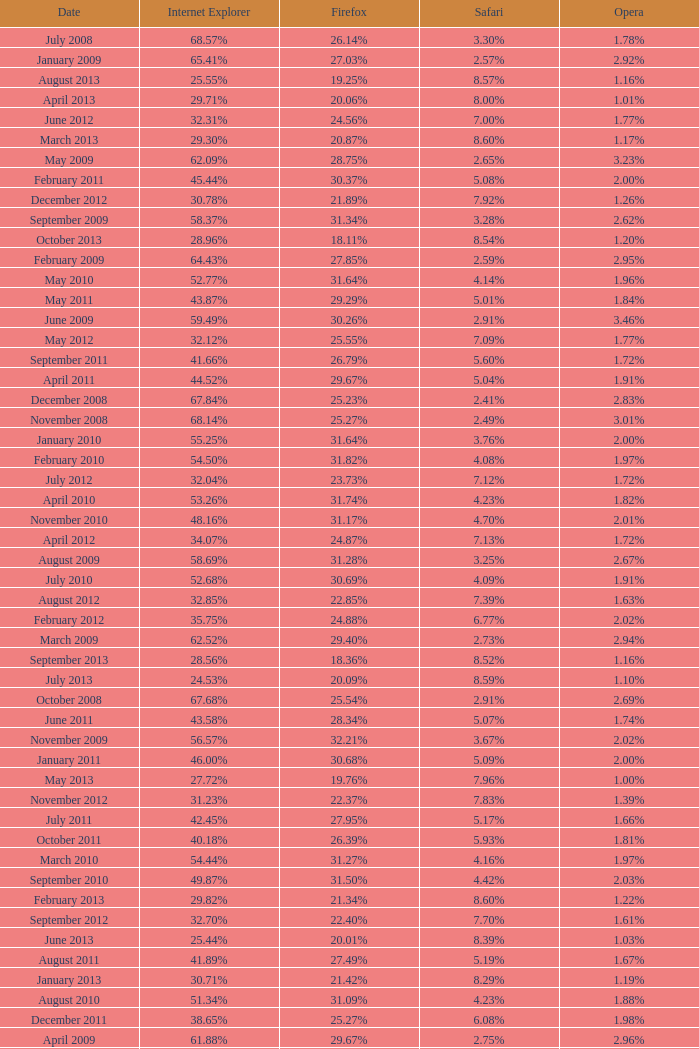What percentage of browsers were using Safari during the period in which 31.27% were using Firefox? 4.16%. 